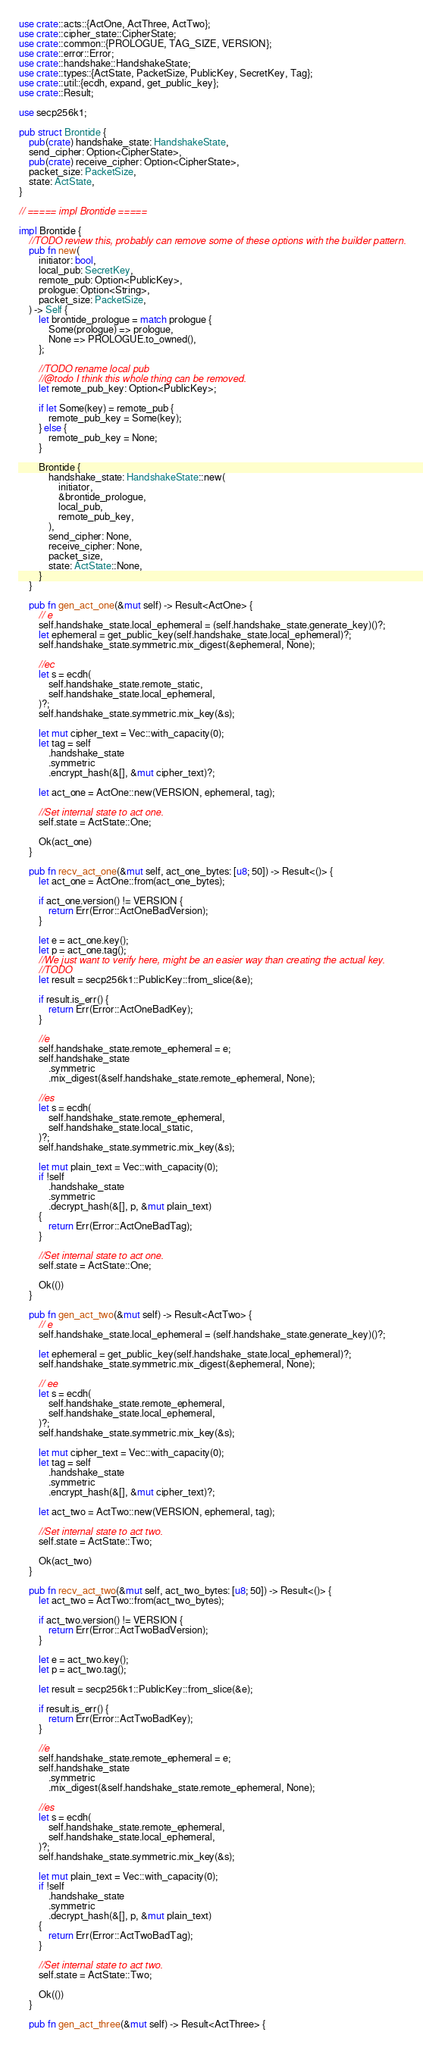Convert code to text. <code><loc_0><loc_0><loc_500><loc_500><_Rust_>use crate::acts::{ActOne, ActThree, ActTwo};
use crate::cipher_state::CipherState;
use crate::common::{PROLOGUE, TAG_SIZE, VERSION};
use crate::error::Error;
use crate::handshake::HandshakeState;
use crate::types::{ActState, PacketSize, PublicKey, SecretKey, Tag};
use crate::util::{ecdh, expand, get_public_key};
use crate::Result;

use secp256k1;

pub struct Brontide {
    pub(crate) handshake_state: HandshakeState,
    send_cipher: Option<CipherState>,
    pub(crate) receive_cipher: Option<CipherState>,
    packet_size: PacketSize,
    state: ActState,
}

// ===== impl Brontide =====

impl Brontide {
    //TODO review this, probably can remove some of these options with the builder pattern.
    pub fn new(
        initiator: bool,
        local_pub: SecretKey,
        remote_pub: Option<PublicKey>,
        prologue: Option<String>,
        packet_size: PacketSize,
    ) -> Self {
        let brontide_prologue = match prologue {
            Some(prologue) => prologue,
            None => PROLOGUE.to_owned(),
        };

        //TODO rename local pub
        //@todo I think this whole thing can be removed.
        let remote_pub_key: Option<PublicKey>;

        if let Some(key) = remote_pub {
            remote_pub_key = Some(key);
        } else {
            remote_pub_key = None;
        }

        Brontide {
            handshake_state: HandshakeState::new(
                initiator,
                &brontide_prologue,
                local_pub,
                remote_pub_key,
            ),
            send_cipher: None,
            receive_cipher: None,
            packet_size,
            state: ActState::None,
        }
    }

    pub fn gen_act_one(&mut self) -> Result<ActOne> {
        // e
        self.handshake_state.local_ephemeral = (self.handshake_state.generate_key)()?;
        let ephemeral = get_public_key(self.handshake_state.local_ephemeral)?;
        self.handshake_state.symmetric.mix_digest(&ephemeral, None);

        //ec
        let s = ecdh(
            self.handshake_state.remote_static,
            self.handshake_state.local_ephemeral,
        )?;
        self.handshake_state.symmetric.mix_key(&s);

        let mut cipher_text = Vec::with_capacity(0);
        let tag = self
            .handshake_state
            .symmetric
            .encrypt_hash(&[], &mut cipher_text)?;

        let act_one = ActOne::new(VERSION, ephemeral, tag);

        //Set internal state to act one.
        self.state = ActState::One;

        Ok(act_one)
    }

    pub fn recv_act_one(&mut self, act_one_bytes: [u8; 50]) -> Result<()> {
        let act_one = ActOne::from(act_one_bytes);

        if act_one.version() != VERSION {
            return Err(Error::ActOneBadVersion);
        }

        let e = act_one.key();
        let p = act_one.tag();
        //We just want to verify here, might be an easier way than creating the actual key.
        //TODO
        let result = secp256k1::PublicKey::from_slice(&e);

        if result.is_err() {
            return Err(Error::ActOneBadKey);
        }

        //e
        self.handshake_state.remote_ephemeral = e;
        self.handshake_state
            .symmetric
            .mix_digest(&self.handshake_state.remote_ephemeral, None);

        //es
        let s = ecdh(
            self.handshake_state.remote_ephemeral,
            self.handshake_state.local_static,
        )?;
        self.handshake_state.symmetric.mix_key(&s);

        let mut plain_text = Vec::with_capacity(0);
        if !self
            .handshake_state
            .symmetric
            .decrypt_hash(&[], p, &mut plain_text)
        {
            return Err(Error::ActOneBadTag);
        }

        //Set internal state to act one.
        self.state = ActState::One;

        Ok(())
    }

    pub fn gen_act_two(&mut self) -> Result<ActTwo> {
        // e
        self.handshake_state.local_ephemeral = (self.handshake_state.generate_key)()?;

        let ephemeral = get_public_key(self.handshake_state.local_ephemeral)?;
        self.handshake_state.symmetric.mix_digest(&ephemeral, None);

        // ee
        let s = ecdh(
            self.handshake_state.remote_ephemeral,
            self.handshake_state.local_ephemeral,
        )?;
        self.handshake_state.symmetric.mix_key(&s);

        let mut cipher_text = Vec::with_capacity(0);
        let tag = self
            .handshake_state
            .symmetric
            .encrypt_hash(&[], &mut cipher_text)?;

        let act_two = ActTwo::new(VERSION, ephemeral, tag);

        //Set internal state to act two.
        self.state = ActState::Two;

        Ok(act_two)
    }

    pub fn recv_act_two(&mut self, act_two_bytes: [u8; 50]) -> Result<()> {
        let act_two = ActTwo::from(act_two_bytes);

        if act_two.version() != VERSION {
            return Err(Error::ActTwoBadVersion);
        }

        let e = act_two.key();
        let p = act_two.tag();

        let result = secp256k1::PublicKey::from_slice(&e);

        if result.is_err() {
            return Err(Error::ActTwoBadKey);
        }

        //e
        self.handshake_state.remote_ephemeral = e;
        self.handshake_state
            .symmetric
            .mix_digest(&self.handshake_state.remote_ephemeral, None);

        //es
        let s = ecdh(
            self.handshake_state.remote_ephemeral,
            self.handshake_state.local_ephemeral,
        )?;
        self.handshake_state.symmetric.mix_key(&s);

        let mut plain_text = Vec::with_capacity(0);
        if !self
            .handshake_state
            .symmetric
            .decrypt_hash(&[], p, &mut plain_text)
        {
            return Err(Error::ActTwoBadTag);
        }

        //Set internal state to act two.
        self.state = ActState::Two;

        Ok(())
    }

    pub fn gen_act_three(&mut self) -> Result<ActThree> {</code> 